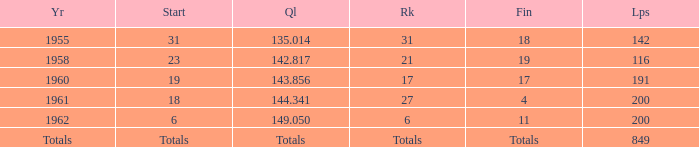What is the year with 116 laps? 1958.0. 